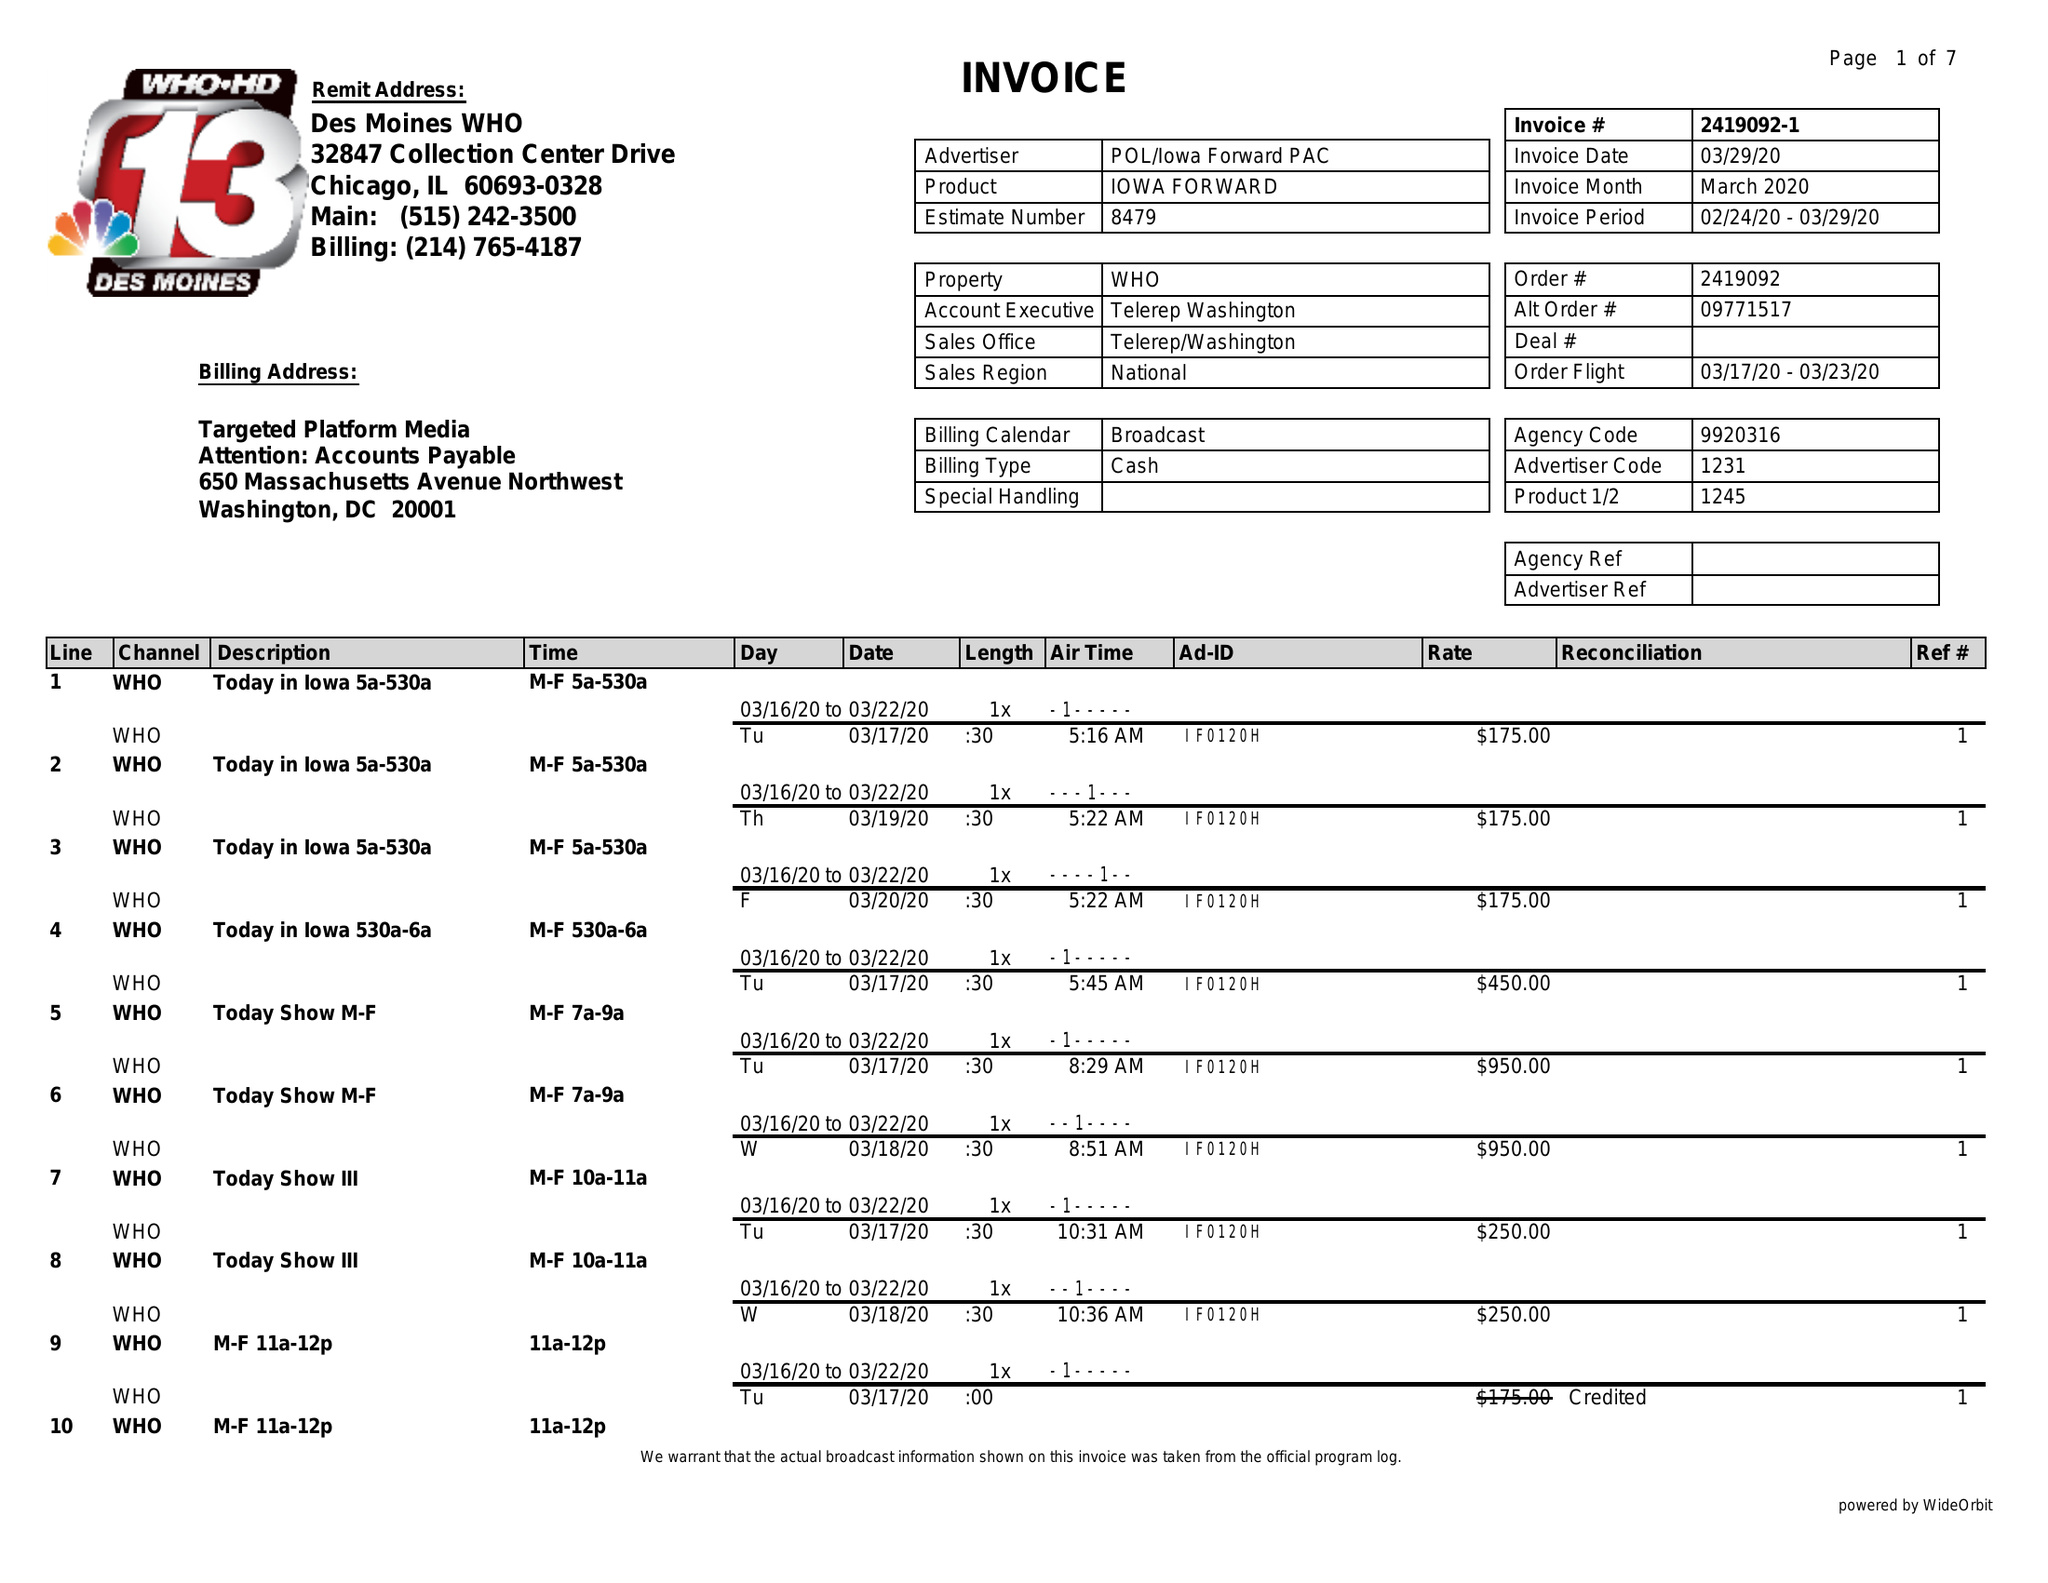What is the value for the flight_from?
Answer the question using a single word or phrase. 03/17/20 